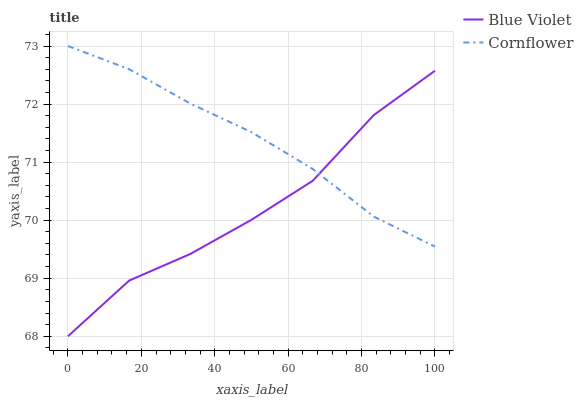Does Blue Violet have the minimum area under the curve?
Answer yes or no. Yes. Does Cornflower have the maximum area under the curve?
Answer yes or no. Yes. Does Blue Violet have the maximum area under the curve?
Answer yes or no. No. Is Cornflower the smoothest?
Answer yes or no. Yes. Is Blue Violet the roughest?
Answer yes or no. Yes. Is Blue Violet the smoothest?
Answer yes or no. No. Does Blue Violet have the lowest value?
Answer yes or no. Yes. Does Cornflower have the highest value?
Answer yes or no. Yes. Does Blue Violet have the highest value?
Answer yes or no. No. Does Blue Violet intersect Cornflower?
Answer yes or no. Yes. Is Blue Violet less than Cornflower?
Answer yes or no. No. Is Blue Violet greater than Cornflower?
Answer yes or no. No. 